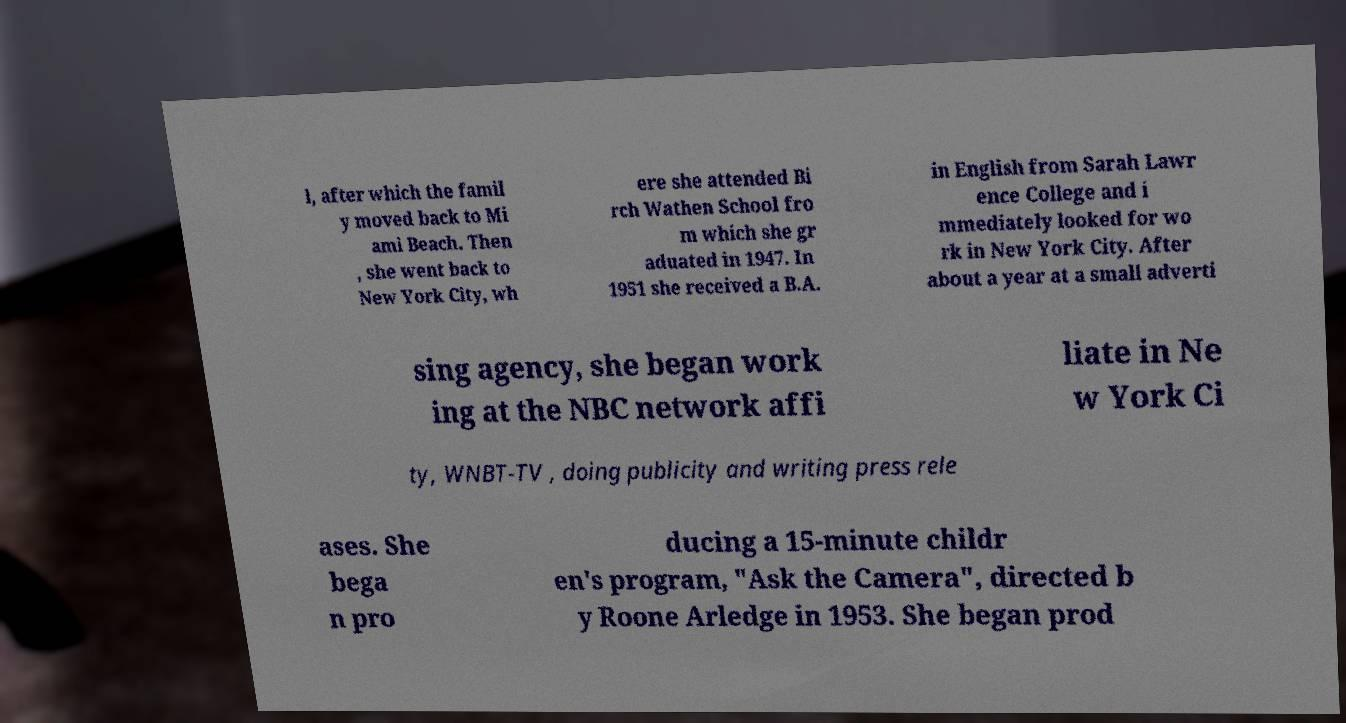What messages or text are displayed in this image? I need them in a readable, typed format. l, after which the famil y moved back to Mi ami Beach. Then , she went back to New York City, wh ere she attended Bi rch Wathen School fro m which she gr aduated in 1947. In 1951 she received a B.A. in English from Sarah Lawr ence College and i mmediately looked for wo rk in New York City. After about a year at a small adverti sing agency, she began work ing at the NBC network affi liate in Ne w York Ci ty, WNBT-TV , doing publicity and writing press rele ases. She bega n pro ducing a 15-minute childr en's program, "Ask the Camera", directed b y Roone Arledge in 1953. She began prod 